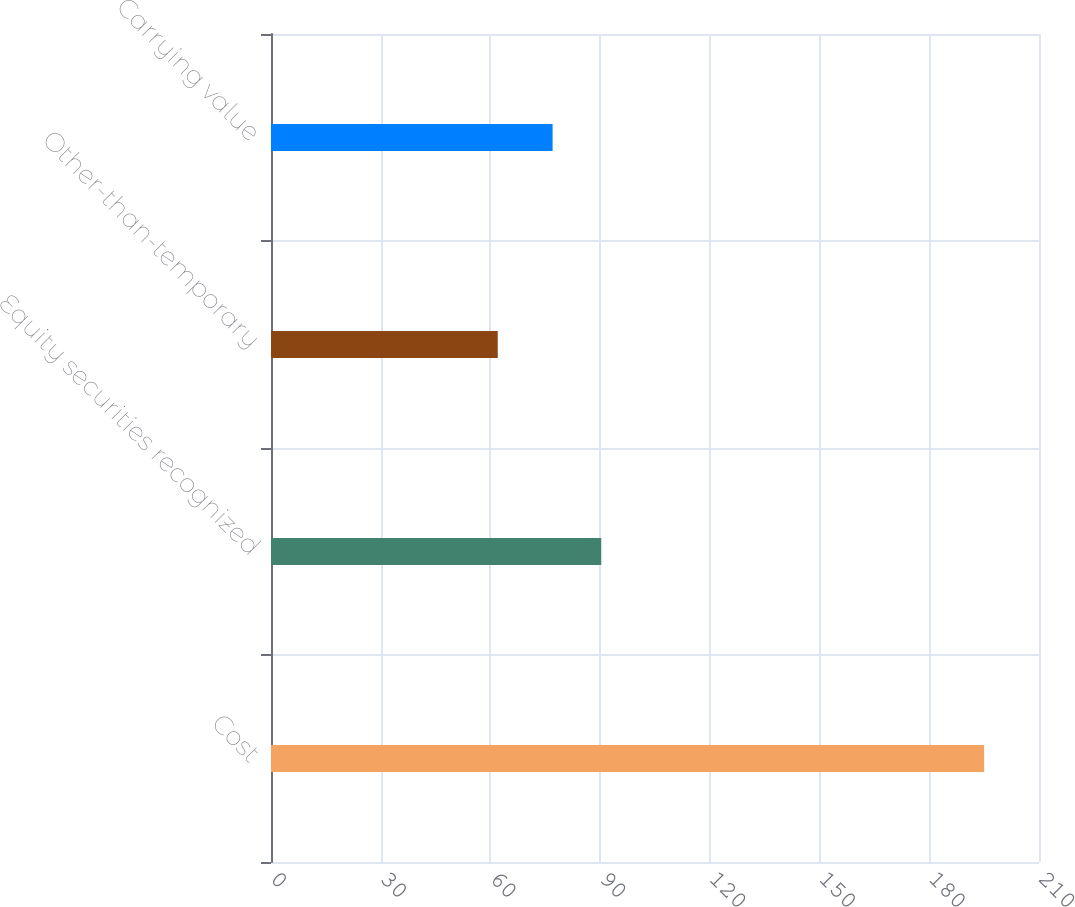Convert chart. <chart><loc_0><loc_0><loc_500><loc_500><bar_chart><fcel>Cost<fcel>Equity securities recognized<fcel>Other-than-temporary<fcel>Carrying value<nl><fcel>195<fcel>90.3<fcel>62<fcel>77<nl></chart> 